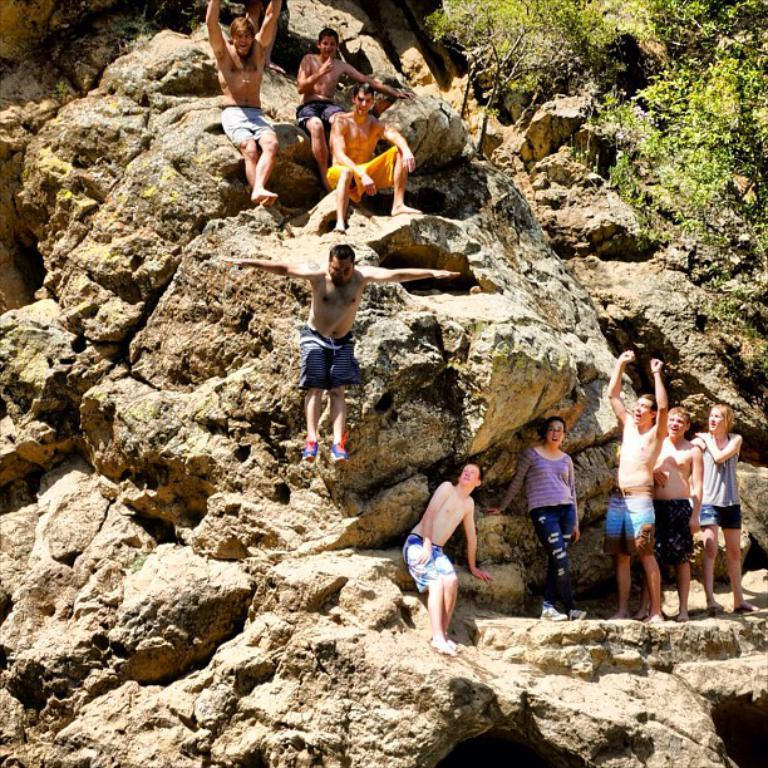Who or what is present in the image? There are people in the image. What natural element can be seen in the image? There is a rock in the image. What type of vegetation is on the right side of the image? There are trees on the right side of the image. What type of bath can be seen in the image? There is no bath present in the image. What thrilling activity are the people participating in the image? The image does not depict any specific activity, so it cannot be determined if it is thrilling or not. 